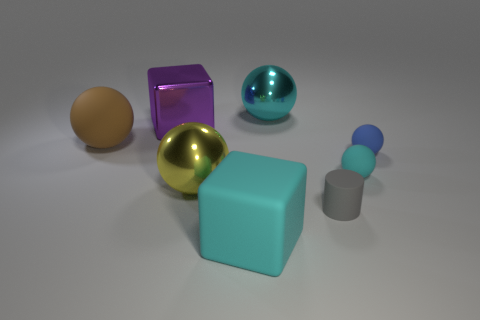Subtract all rubber balls. How many balls are left? 2 Subtract all blue spheres. How many spheres are left? 4 Subtract all gray cubes. How many yellow spheres are left? 1 Subtract all metallic cubes. Subtract all tiny cyan matte things. How many objects are left? 6 Add 4 cyan things. How many cyan things are left? 7 Add 1 gray matte spheres. How many gray matte spheres exist? 1 Add 1 cyan balls. How many objects exist? 9 Subtract 1 cyan blocks. How many objects are left? 7 Subtract all balls. How many objects are left? 3 Subtract 1 balls. How many balls are left? 4 